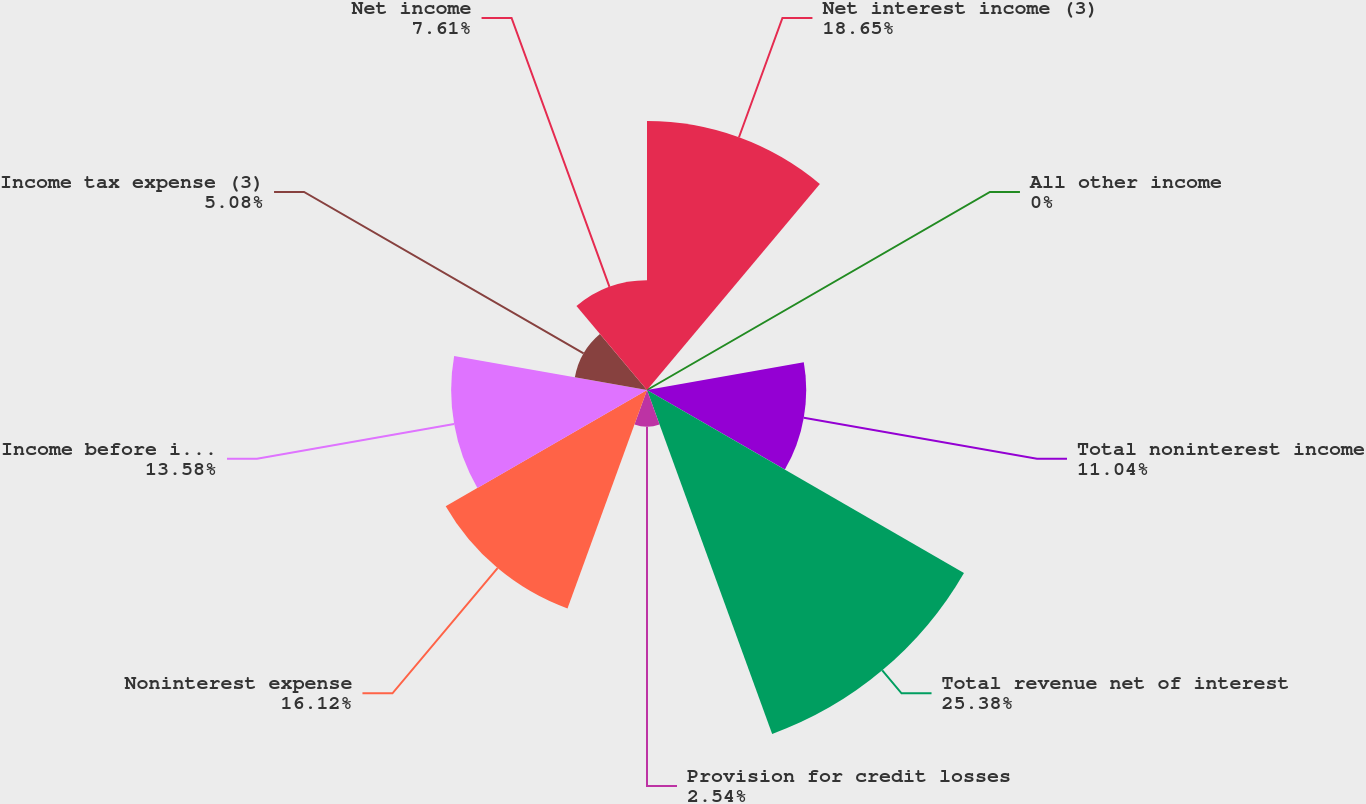Convert chart to OTSL. <chart><loc_0><loc_0><loc_500><loc_500><pie_chart><fcel>Net interest income (3)<fcel>All other income<fcel>Total noninterest income<fcel>Total revenue net of interest<fcel>Provision for credit losses<fcel>Noninterest expense<fcel>Income before income taxes<fcel>Income tax expense (3)<fcel>Net income<nl><fcel>18.65%<fcel>0.0%<fcel>11.04%<fcel>25.38%<fcel>2.54%<fcel>16.12%<fcel>13.58%<fcel>5.08%<fcel>7.61%<nl></chart> 